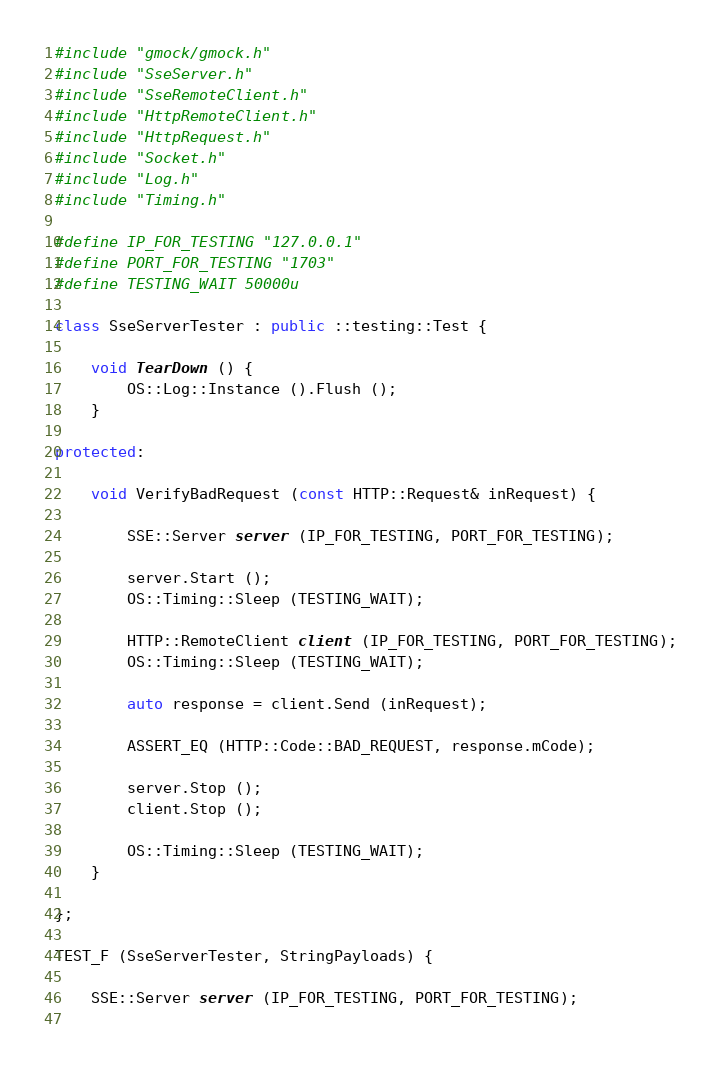Convert code to text. <code><loc_0><loc_0><loc_500><loc_500><_C++_>
#include "gmock/gmock.h"
#include "SseServer.h"
#include "SseRemoteClient.h"
#include "HttpRemoteClient.h"
#include "HttpRequest.h"
#include "Socket.h"
#include "Log.h"
#include "Timing.h"

#define IP_FOR_TESTING "127.0.0.1"
#define PORT_FOR_TESTING "1703"
#define TESTING_WAIT 50000u

class SseServerTester : public ::testing::Test {

    void TearDown () {
        OS::Log::Instance ().Flush ();
    }
    
protected:

    void VerifyBadRequest (const HTTP::Request& inRequest) {
        
        SSE::Server server (IP_FOR_TESTING, PORT_FOR_TESTING);
        
        server.Start ();
        OS::Timing::Sleep (TESTING_WAIT);
        
        HTTP::RemoteClient client (IP_FOR_TESTING, PORT_FOR_TESTING);
        OS::Timing::Sleep (TESTING_WAIT);
        
        auto response = client.Send (inRequest);
        
        ASSERT_EQ (HTTP::Code::BAD_REQUEST, response.mCode);
        
        server.Stop ();
        client.Stop ();
        
        OS::Timing::Sleep (TESTING_WAIT);
    }

};

TEST_F (SseServerTester, StringPayloads) {
    
    SSE::Server server (IP_FOR_TESTING, PORT_FOR_TESTING);
    </code> 